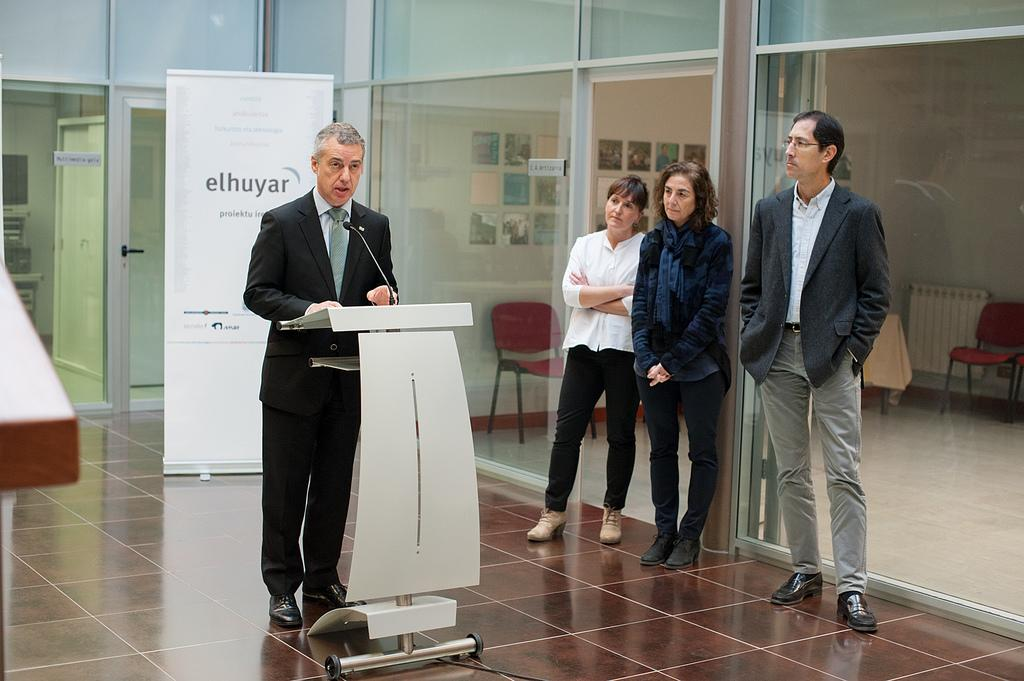How many people are in the image? There are four persons in the image. What is one person doing in the image? One person is talking on a microphone. What can be seen near the person talking on the microphone? There is a podium in the image. What is written or displayed on the banner in the image? The content of the banner is not mentioned in the facts, so we cannot determine what is written or displayed on it. What type of surface is visible in the image? The image shows a floor. What objects are present for seating in the image? There are chairs in the image. What objects are present for drinking in the image? There are glasses in the image. What architectural features are present in the image? There are doors in the image. What is hanging on the wall in the image? There are frames on the wall in the image. What type of competition is taking place in the image? There is no indication of a competition in the image. What facial expression does the person talking on the microphone have? The facts do not mention the facial expression of the person talking on the microphone. 